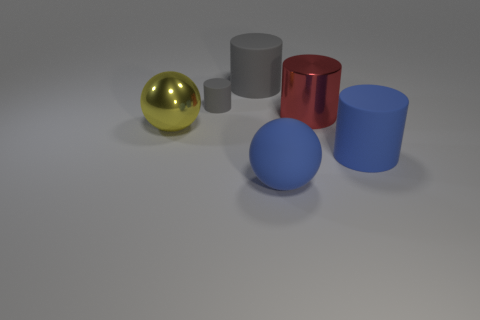The large metallic sphere is what color?
Your answer should be very brief. Yellow. How many big things are either spheres or brown balls?
Your response must be concise. 2. There is a big thing that is the same color as the small rubber cylinder; what material is it?
Ensure brevity in your answer.  Rubber. Does the sphere that is to the right of the small thing have the same material as the blue thing to the right of the large rubber ball?
Offer a terse response. Yes. Are any large green matte spheres visible?
Provide a short and direct response. No. Are there more red cylinders in front of the small gray object than tiny gray cylinders that are in front of the yellow sphere?
Give a very brief answer. Yes. There is a blue thing that is the same shape as the big yellow metal thing; what is it made of?
Provide a succinct answer. Rubber. Do the matte object that is on the right side of the big blue sphere and the large ball right of the large gray matte thing have the same color?
Provide a short and direct response. Yes. There is a yellow metal thing; what shape is it?
Your response must be concise. Sphere. Are there more large objects that are behind the large matte ball than small gray cylinders?
Offer a terse response. Yes. 